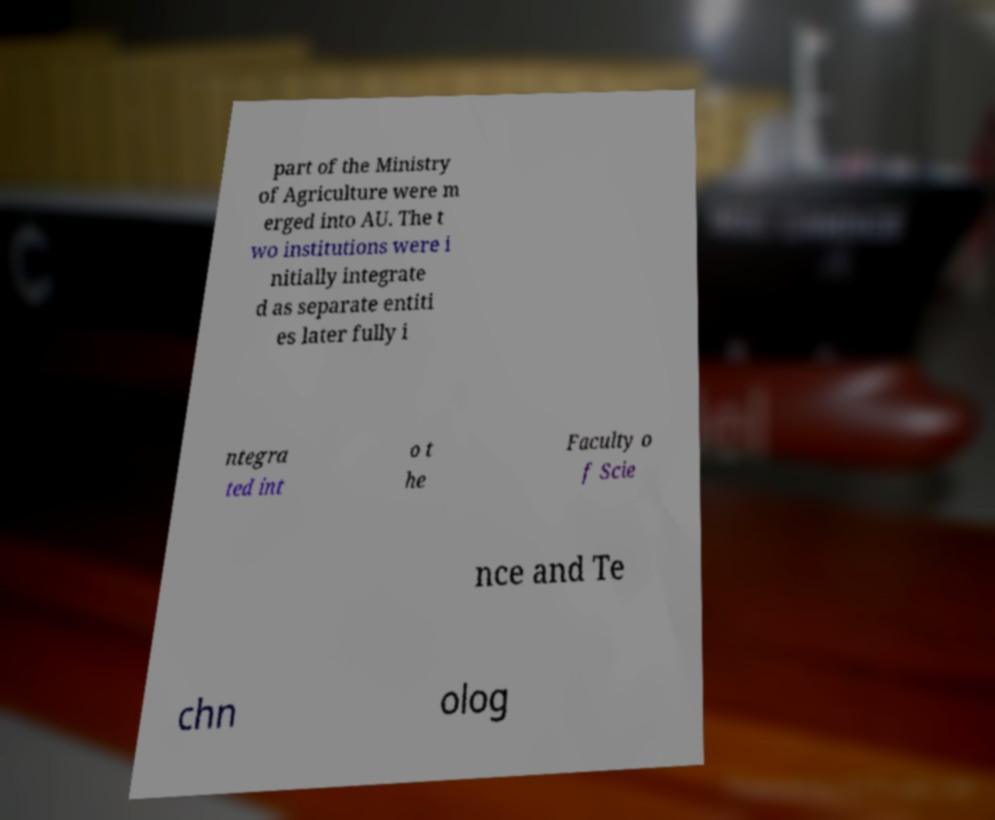I need the written content from this picture converted into text. Can you do that? part of the Ministry of Agriculture were m erged into AU. The t wo institutions were i nitially integrate d as separate entiti es later fully i ntegra ted int o t he Faculty o f Scie nce and Te chn olog 